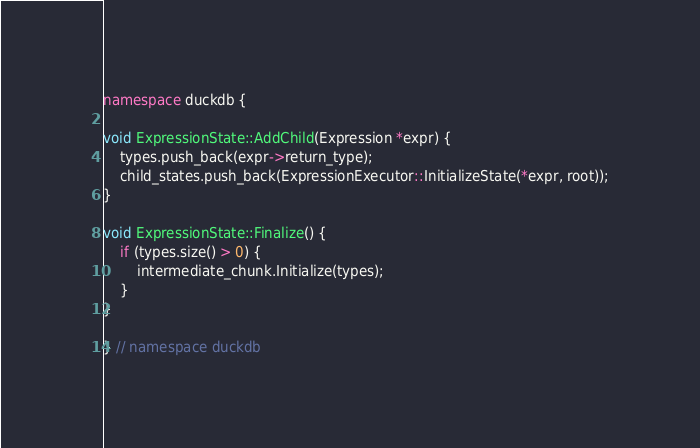<code> <loc_0><loc_0><loc_500><loc_500><_C++_>
namespace duckdb {

void ExpressionState::AddChild(Expression *expr) {
	types.push_back(expr->return_type);
	child_states.push_back(ExpressionExecutor::InitializeState(*expr, root));
}

void ExpressionState::Finalize() {
	if (types.size() > 0) {
		intermediate_chunk.Initialize(types);
	}
}

} // namespace duckdb
</code> 